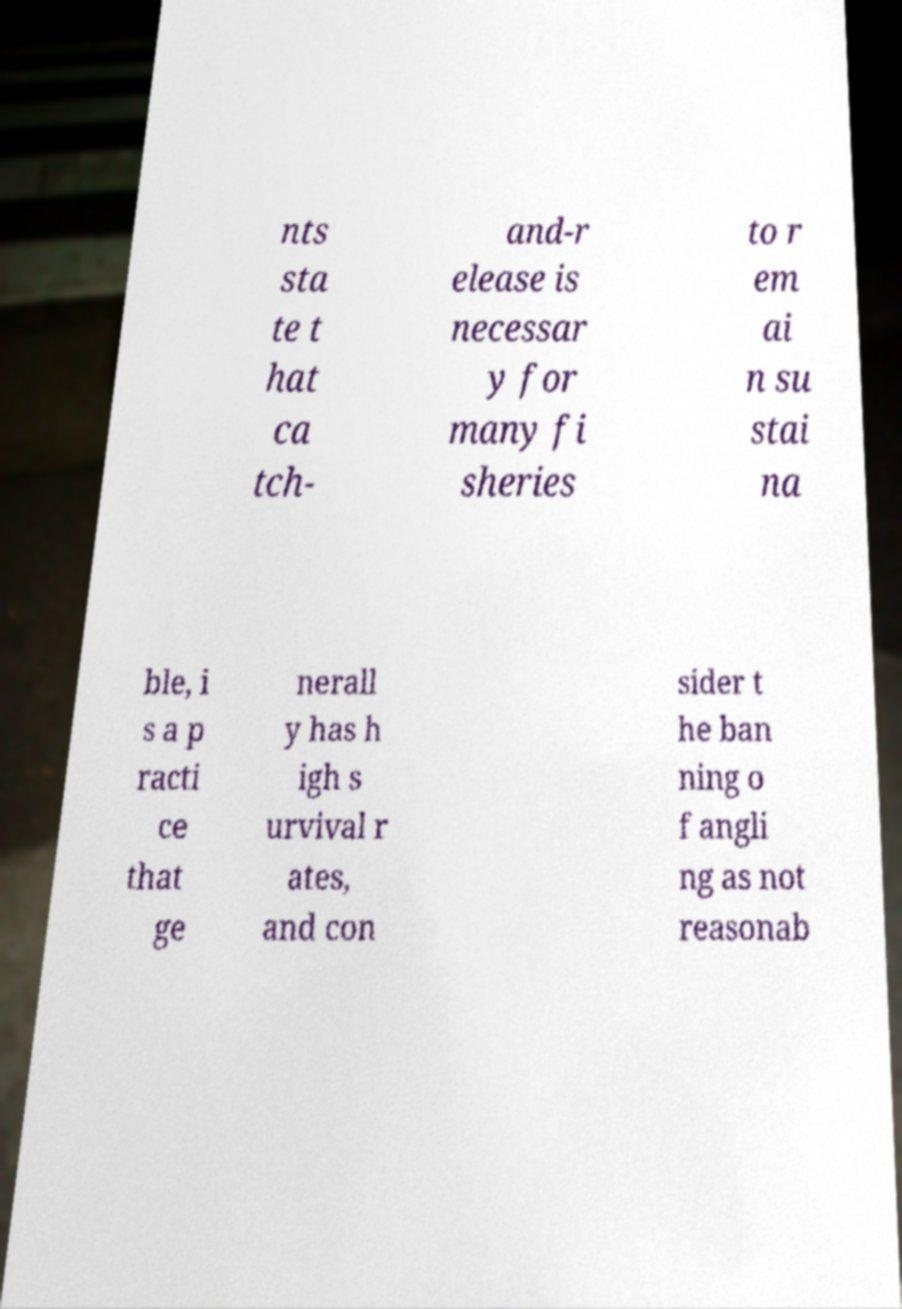Please read and relay the text visible in this image. What does it say? nts sta te t hat ca tch- and-r elease is necessar y for many fi sheries to r em ai n su stai na ble, i s a p racti ce that ge nerall y has h igh s urvival r ates, and con sider t he ban ning o f angli ng as not reasonab 